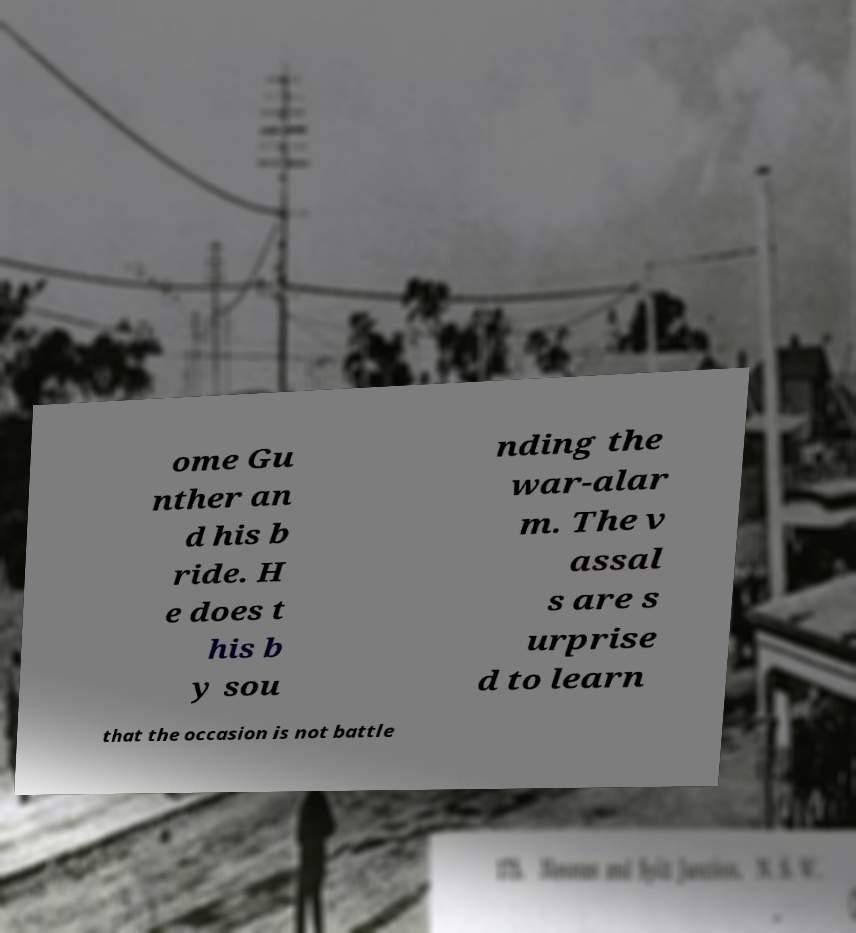There's text embedded in this image that I need extracted. Can you transcribe it verbatim? ome Gu nther an d his b ride. H e does t his b y sou nding the war-alar m. The v assal s are s urprise d to learn that the occasion is not battle 